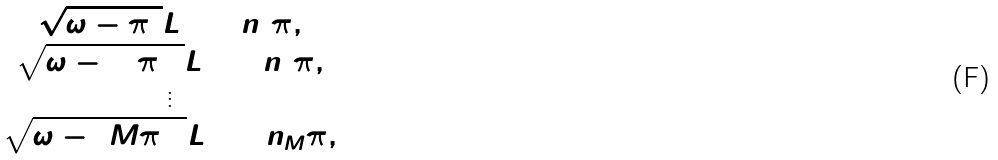<formula> <loc_0><loc_0><loc_500><loc_500>\begin{array} { c } \sqrt { \omega - \pi ^ { 2 } } L = 2 n _ { 1 } \pi , \\ \sqrt { \omega - ( 2 \pi ) ^ { 2 } } L = 2 n _ { 2 } \pi , \\ \vdots \\ \sqrt { \omega - ( M \pi ) ^ { 2 } } L = 2 n _ { M } \pi , \\ \end{array}</formula> 